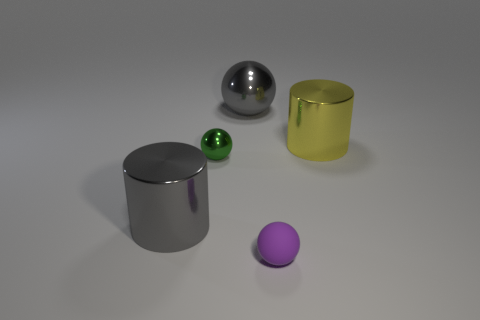Subtract all big gray metal spheres. How many spheres are left? 2 Subtract all purple cylinders. Subtract all yellow blocks. How many cylinders are left? 2 Subtract all brown cylinders. How many gray balls are left? 1 Subtract all large gray things. Subtract all big gray metal cylinders. How many objects are left? 2 Add 2 yellow objects. How many yellow objects are left? 3 Add 5 tiny green rubber cylinders. How many tiny green rubber cylinders exist? 5 Add 1 green metal balls. How many objects exist? 6 Subtract all green spheres. How many spheres are left? 2 Subtract 1 yellow cylinders. How many objects are left? 4 Subtract all balls. How many objects are left? 2 